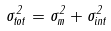<formula> <loc_0><loc_0><loc_500><loc_500>\sigma _ { t o t } ^ { 2 } = \sigma _ { m } ^ { 2 } + \sigma _ { i n t } ^ { 2 }</formula> 